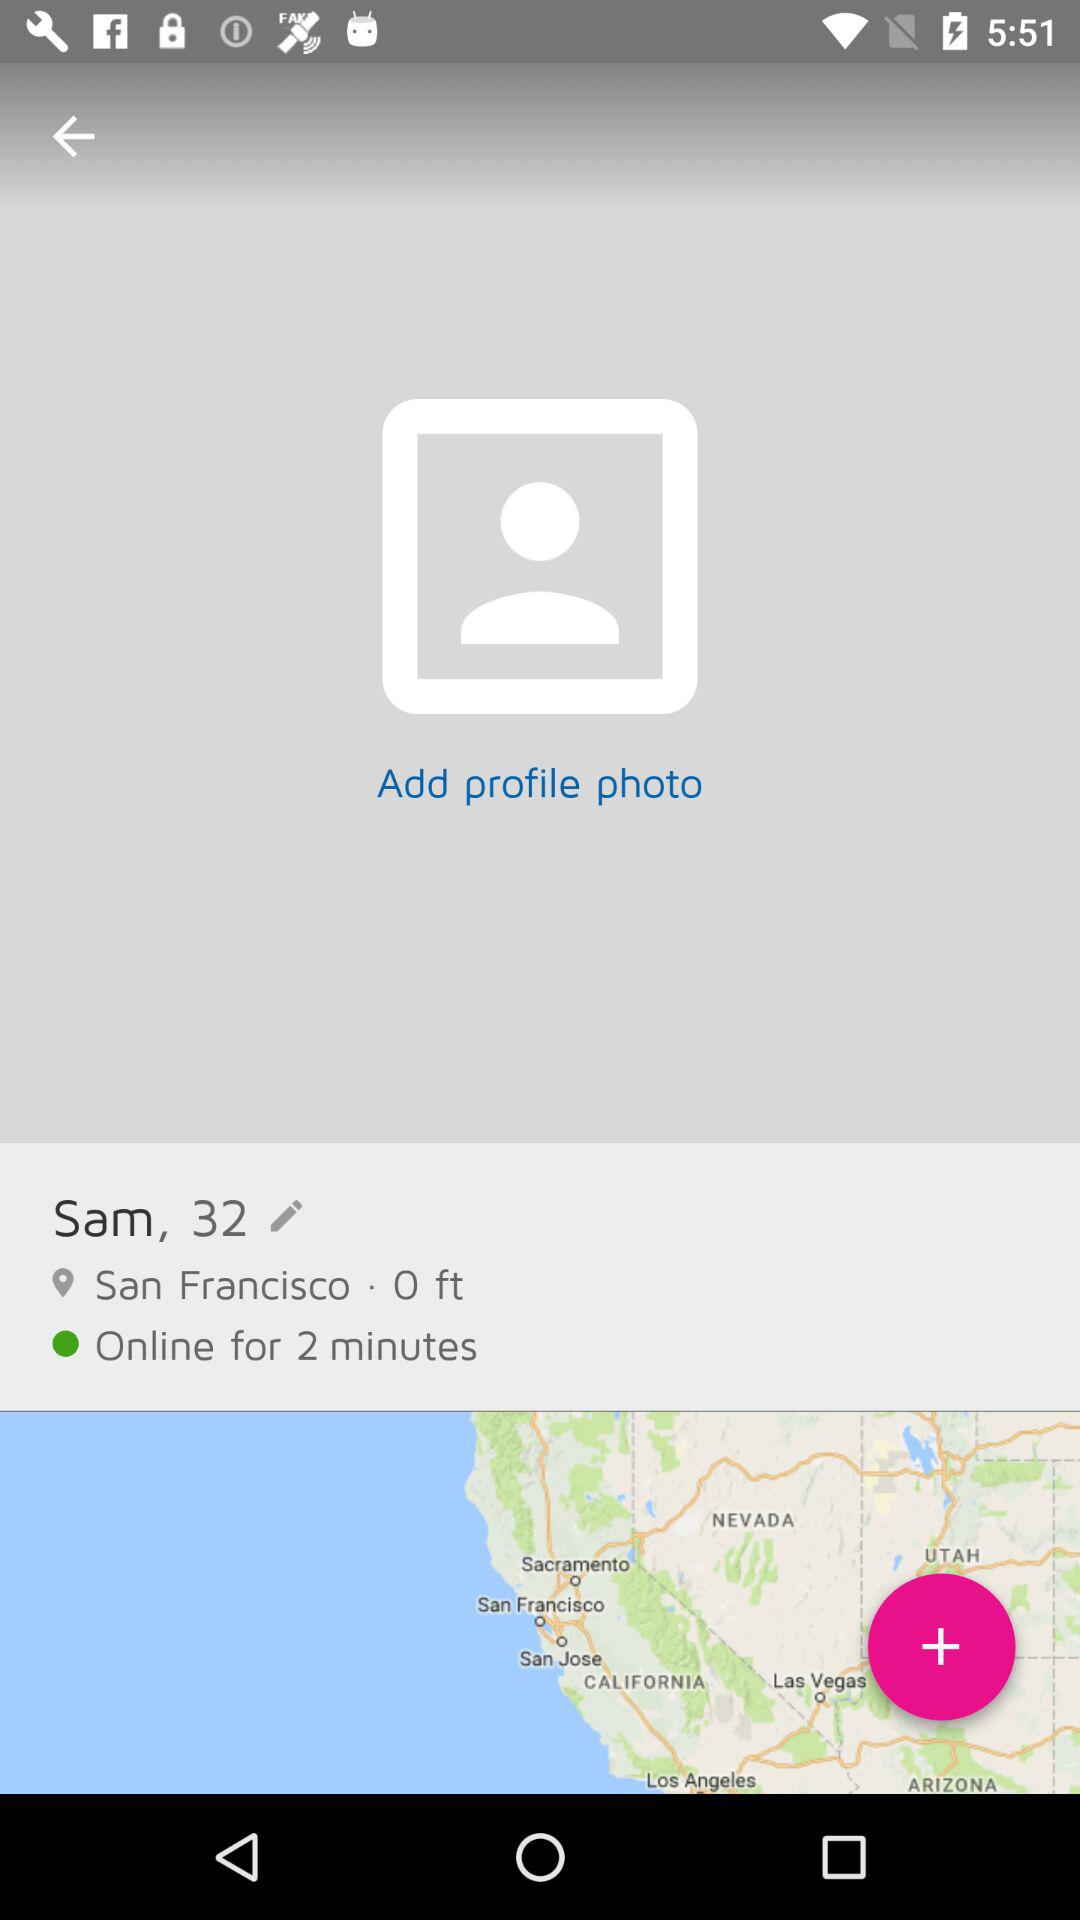How old is Sam? Sam is 32 years old. 